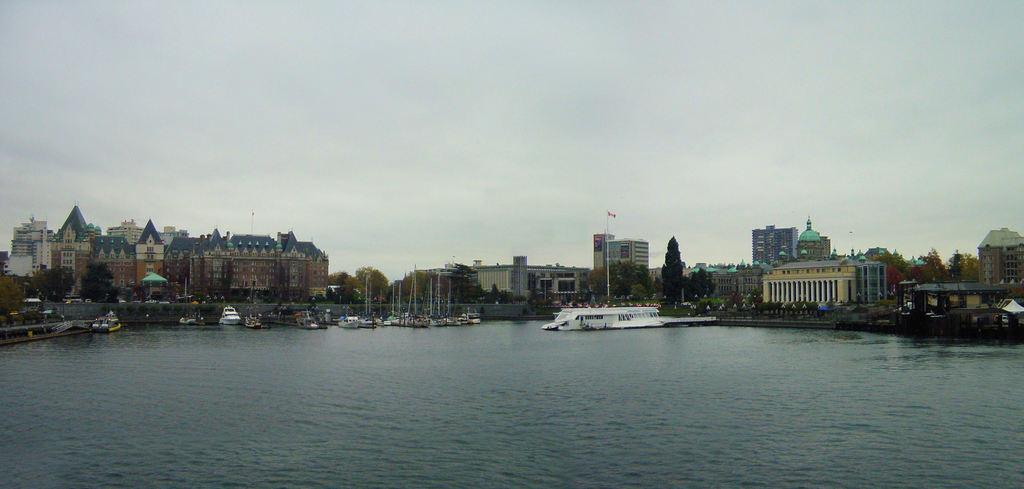Could you give a brief overview of what you see in this image? In this image in the middle, there are boats, poles, buildings, trees, flag, tents, sky and clouds. At the bottom there are waves and water. 